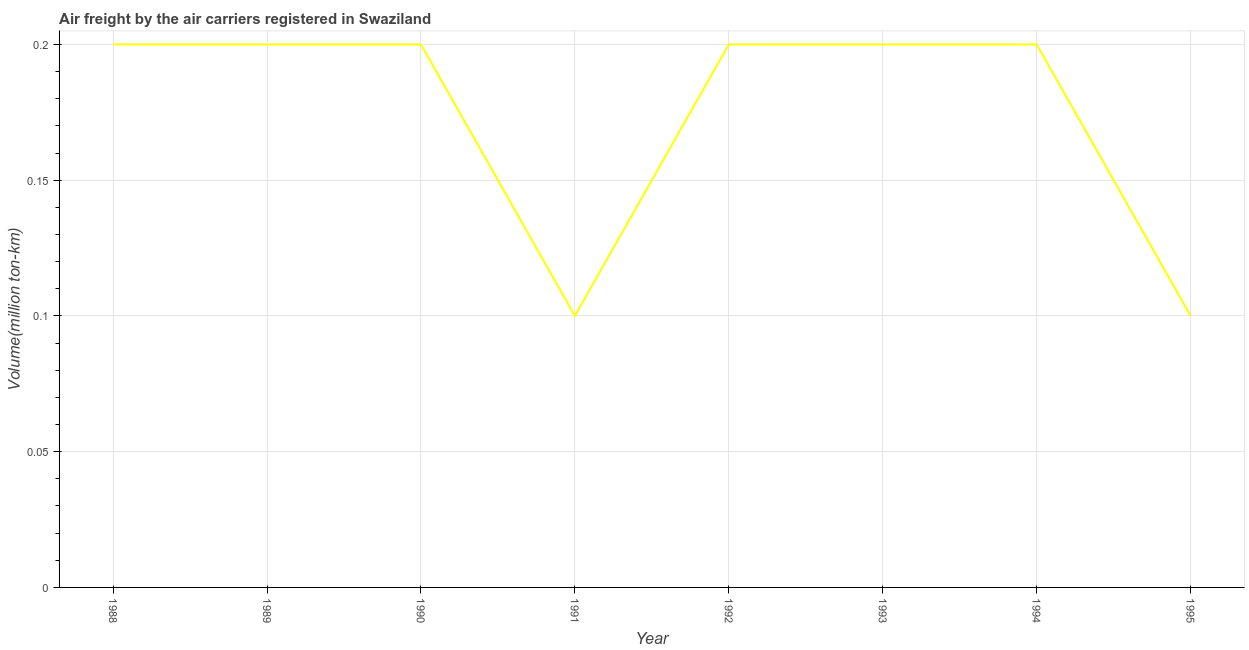What is the air freight in 1989?
Your answer should be very brief. 0.2. Across all years, what is the maximum air freight?
Make the answer very short. 0.2. Across all years, what is the minimum air freight?
Your answer should be very brief. 0.1. In which year was the air freight minimum?
Ensure brevity in your answer.  1991. What is the sum of the air freight?
Ensure brevity in your answer.  1.4. What is the average air freight per year?
Offer a terse response. 0.18. What is the median air freight?
Keep it short and to the point. 0.2. In how many years, is the air freight greater than 0.01 million ton-km?
Provide a short and direct response. 8. Is the difference between the air freight in 1988 and 1992 greater than the difference between any two years?
Keep it short and to the point. No. Is the sum of the air freight in 1992 and 1993 greater than the maximum air freight across all years?
Make the answer very short. Yes. What is the difference between the highest and the lowest air freight?
Your answer should be compact. 0.1. In how many years, is the air freight greater than the average air freight taken over all years?
Make the answer very short. 6. How many years are there in the graph?
Offer a terse response. 8. What is the title of the graph?
Your response must be concise. Air freight by the air carriers registered in Swaziland. What is the label or title of the X-axis?
Offer a very short reply. Year. What is the label or title of the Y-axis?
Offer a very short reply. Volume(million ton-km). What is the Volume(million ton-km) of 1988?
Offer a terse response. 0.2. What is the Volume(million ton-km) in 1989?
Ensure brevity in your answer.  0.2. What is the Volume(million ton-km) in 1990?
Offer a terse response. 0.2. What is the Volume(million ton-km) in 1991?
Your response must be concise. 0.1. What is the Volume(million ton-km) of 1992?
Keep it short and to the point. 0.2. What is the Volume(million ton-km) of 1993?
Offer a very short reply. 0.2. What is the Volume(million ton-km) in 1994?
Make the answer very short. 0.2. What is the Volume(million ton-km) of 1995?
Your response must be concise. 0.1. What is the difference between the Volume(million ton-km) in 1988 and 1989?
Provide a short and direct response. 0. What is the difference between the Volume(million ton-km) in 1988 and 1991?
Give a very brief answer. 0.1. What is the difference between the Volume(million ton-km) in 1988 and 1993?
Make the answer very short. 0. What is the difference between the Volume(million ton-km) in 1989 and 1990?
Ensure brevity in your answer.  0. What is the difference between the Volume(million ton-km) in 1989 and 1991?
Provide a succinct answer. 0.1. What is the difference between the Volume(million ton-km) in 1989 and 1992?
Your answer should be very brief. 0. What is the difference between the Volume(million ton-km) in 1990 and 1991?
Offer a very short reply. 0.1. What is the difference between the Volume(million ton-km) in 1990 and 1992?
Provide a short and direct response. 0. What is the difference between the Volume(million ton-km) in 1990 and 1995?
Ensure brevity in your answer.  0.1. What is the difference between the Volume(million ton-km) in 1991 and 1993?
Offer a very short reply. -0.1. What is the difference between the Volume(million ton-km) in 1992 and 1993?
Offer a very short reply. 0. What is the difference between the Volume(million ton-km) in 1993 and 1995?
Offer a terse response. 0.1. What is the ratio of the Volume(million ton-km) in 1988 to that in 1990?
Provide a succinct answer. 1. What is the ratio of the Volume(million ton-km) in 1988 to that in 1995?
Ensure brevity in your answer.  2. What is the ratio of the Volume(million ton-km) in 1989 to that in 1991?
Provide a succinct answer. 2. What is the ratio of the Volume(million ton-km) in 1989 to that in 1994?
Give a very brief answer. 1. What is the ratio of the Volume(million ton-km) in 1990 to that in 1991?
Offer a very short reply. 2. What is the ratio of the Volume(million ton-km) in 1990 to that in 1993?
Offer a terse response. 1. What is the ratio of the Volume(million ton-km) in 1991 to that in 1992?
Make the answer very short. 0.5. What is the ratio of the Volume(million ton-km) in 1991 to that in 1994?
Your response must be concise. 0.5. What is the ratio of the Volume(million ton-km) in 1992 to that in 1993?
Make the answer very short. 1. What is the ratio of the Volume(million ton-km) in 1992 to that in 1994?
Make the answer very short. 1. What is the ratio of the Volume(million ton-km) in 1992 to that in 1995?
Provide a short and direct response. 2. What is the ratio of the Volume(million ton-km) in 1993 to that in 1994?
Your answer should be very brief. 1. What is the ratio of the Volume(million ton-km) in 1993 to that in 1995?
Offer a terse response. 2. 